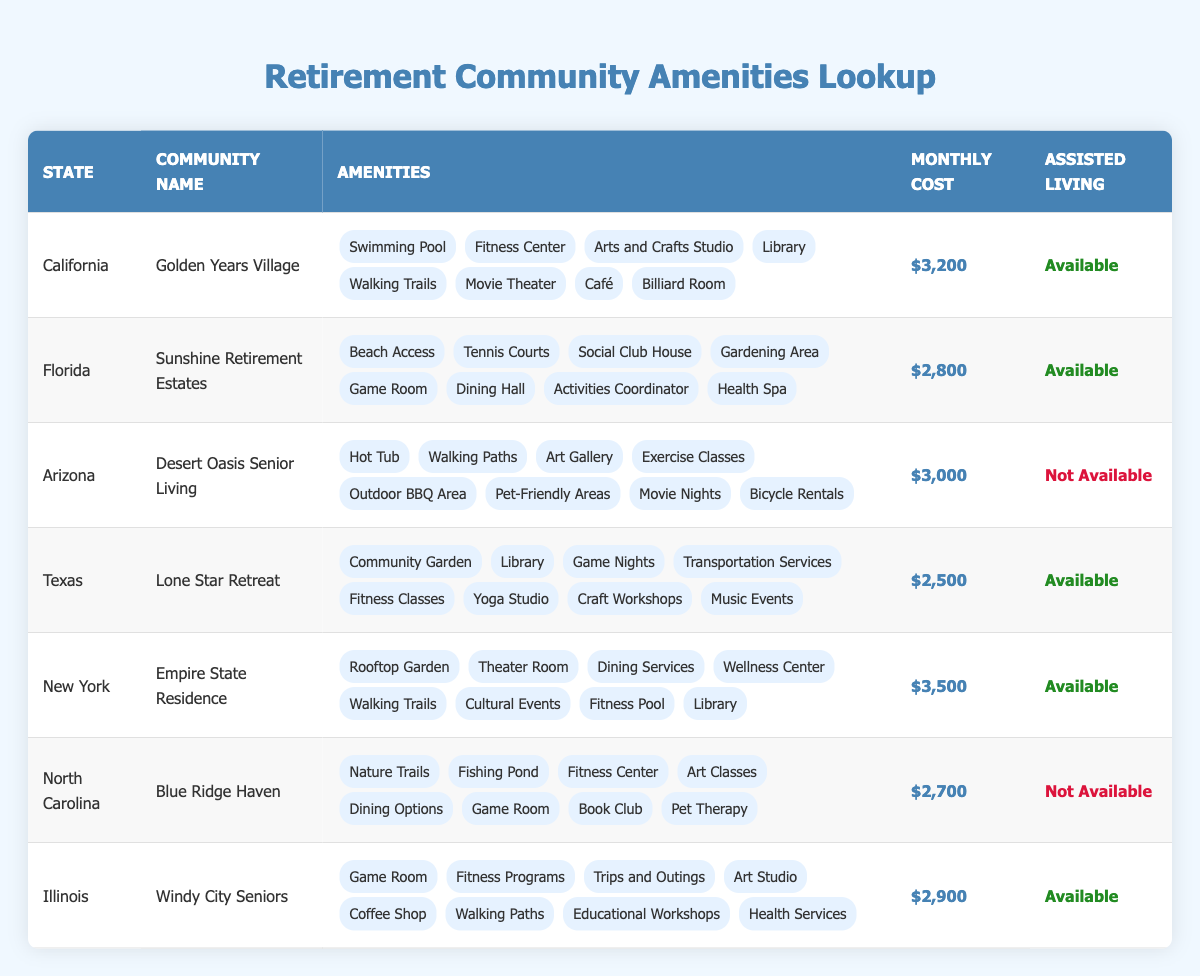What is the monthly cost of Golden Years Village in California? The table shows that the average cost per month for Golden Years Village located in California is listed as $3,200.
Answer: $3,200 Which retirement community has beach access? The table indicates that Sunshine Retirement Estates in Florida has beach access listed among its amenities.
Answer: Sunshine Retirement Estates How many states have assisted living options available? By counting the entries in the table, we see that California, Florida, Texas, Illinois, and New York each have assisted living options available. This totals to five states.
Answer: 5 What is the difference in monthly cost between Empire State Residence and Lone Star Retreat? Empire State Residence has an average monthly cost of $3,500, while Lone Star Retreat's cost is $2,500. The difference can be calculated by subtracting $2,500 from $3,500, resulting in a difference of $1,000.
Answer: $1,000 Is the Desert Oasis Senior Living in Arizona pet-friendly? According to the table, Desert Oasis Senior Living lists pet-friendly areas as one of its amenities, indicating that it is indeed pet-friendly.
Answer: Yes What is the average monthly cost of retirement communities without assisted living options? The retirement communities without assisted living options are Desert Oasis Senior Living (Arizona, $3,000) and Blue Ridge Haven (North Carolina, $2,700). The average is calculated by summing these costs ($3,000 + $2,700 = $5,700) and dividing by the number of communities (2), resulting in an average of $2,850.
Answer: $2,850 How many amenities does the Lone Star Retreat in Texas offer? The table lists 8 different amenities provided by Lone Star Retreat, including a community garden, library, game nights, and more.
Answer: 8 Which community has the highest average monthly cost? By comparing the average costs from the table, we see that Empire State Residence in New York has the highest monthly cost at $3,500 compared to other communities.
Answer: Empire State Residence Does Blue Ridge Haven offer a game room? The table shows that Blue Ridge Haven in North Carolina lists a game room among its amenities, confirming that it does offer a game room.
Answer: Yes 